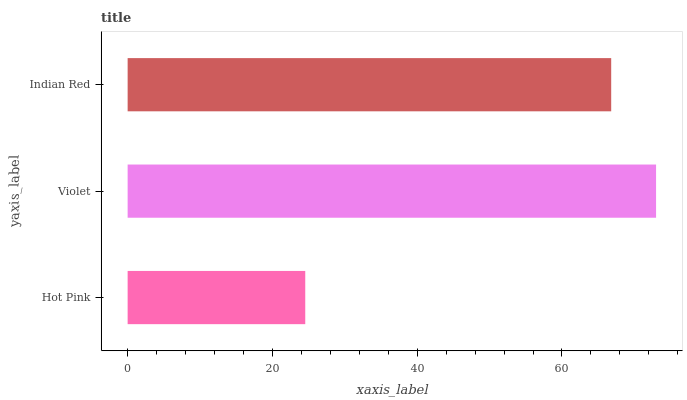Is Hot Pink the minimum?
Answer yes or no. Yes. Is Violet the maximum?
Answer yes or no. Yes. Is Indian Red the minimum?
Answer yes or no. No. Is Indian Red the maximum?
Answer yes or no. No. Is Violet greater than Indian Red?
Answer yes or no. Yes. Is Indian Red less than Violet?
Answer yes or no. Yes. Is Indian Red greater than Violet?
Answer yes or no. No. Is Violet less than Indian Red?
Answer yes or no. No. Is Indian Red the high median?
Answer yes or no. Yes. Is Indian Red the low median?
Answer yes or no. Yes. Is Hot Pink the high median?
Answer yes or no. No. Is Hot Pink the low median?
Answer yes or no. No. 